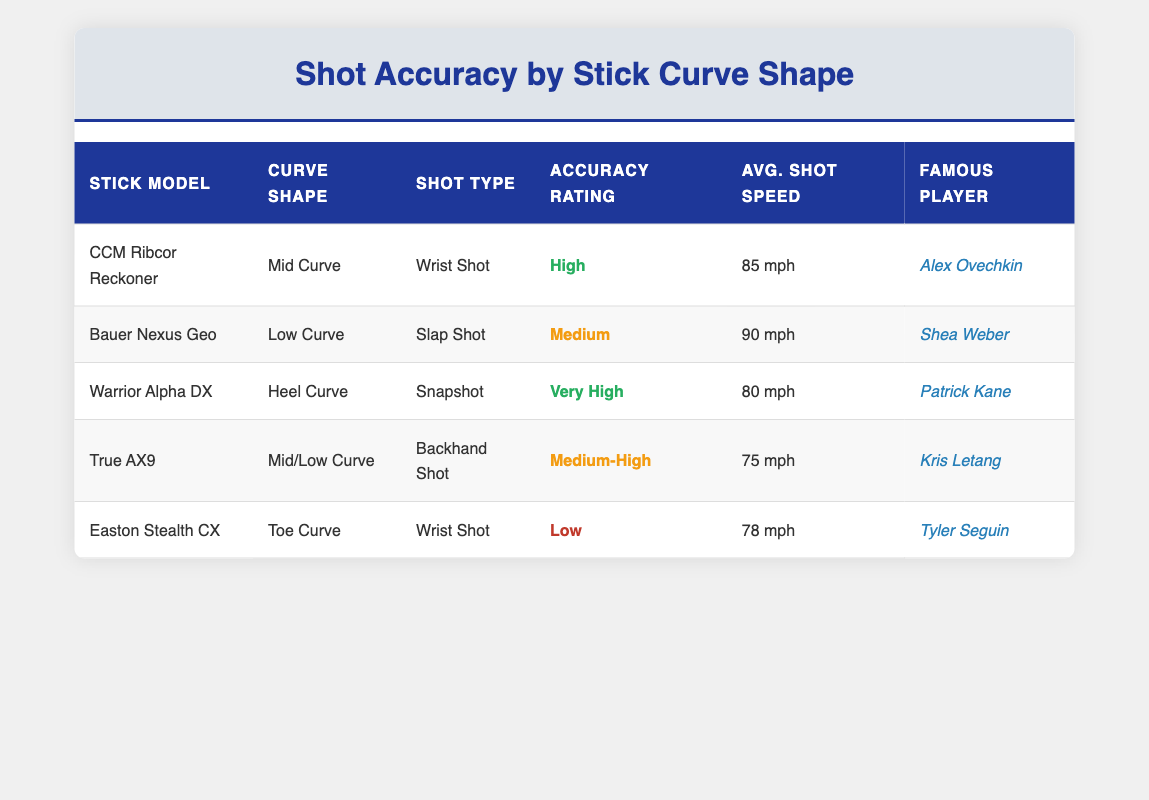What is the accuracy rating for the CCM Ribcor Reckoner stick? According to the table, the accuracy rating for the CCM Ribcor Reckoner is listed as "High."
Answer: High Which stick has the highest average shot speed and what is that speed? The Bauer Nexus Geo has the highest average shot speed at "90 mph."
Answer: 90 mph Did the Easton Stealth CX achieve a medium accuracy rating? Checking the table, the Easton Stealth CX has an accuracy rating of "Low," which means it did not achieve a medium rating.
Answer: No What is the average shot speed of sticks with 'Curve' types that have a high accuracy rating? The sticks with high accuracy ratings are the CCM Ribcor Reckoner (85 mph) and the Warrior Alpha DX (80 mph). To find the average: (85 + 80) / 2 = 82.5 mph.
Answer: 82.5 mph Is there a stick in the table associated with a famous player known for wrist shots? The CCM Ribcor Reckoner is associated with Alex Ovechkin, who is known for his wrist shots.
Answer: Yes What percentage of the sticks listed have a 'Medium' accuracy rating? There are 5 sticks total, 2 of which (Bauer Nexus Geo and True AX9) have a 'Medium' accuracy rating. To find the percentage: (2/5) * 100 = 40%.
Answer: 40% Among the sticks listed, which shot type had the lowest average shot speed? The lowest average shot speed is from the True AX9 with an average speed of "75 mph".
Answer: 75 mph Compare the accuracy ratings of the sticks with a Toe Curve and a Heel Curve. The Easton Stealth CX, which has a Toe Curve, has a "Low" accuracy rating, while the Warrior Alpha DX with a Heel Curve has a "Very High" accuracy rating.
Answer: Heel Curve has Very High, Toe Curve has Low Based on the data, what is the total shot speed of all listed sticks? To calculate the total shot speed, we sum all average shot speeds: 85 + 90 + 80 + 75 + 78 = 408 mph.
Answer: 408 mph 